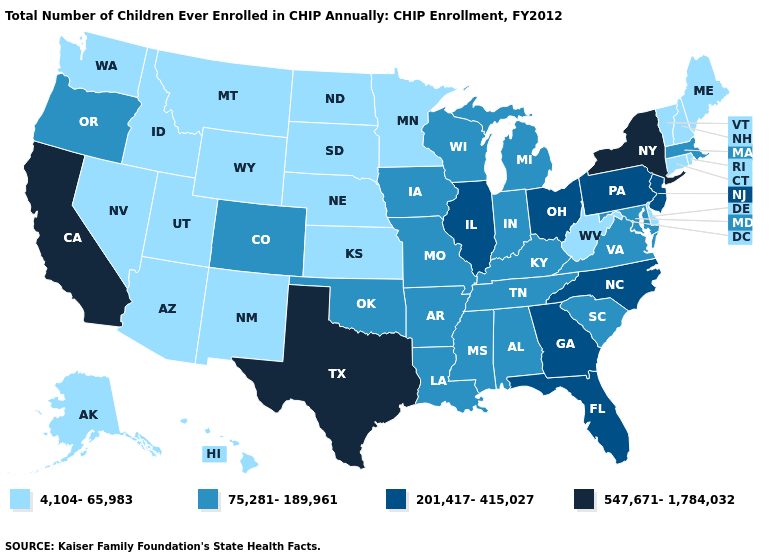Does Oregon have a higher value than Minnesota?
Short answer required. Yes. Does the first symbol in the legend represent the smallest category?
Concise answer only. Yes. What is the value of Louisiana?
Give a very brief answer. 75,281-189,961. Name the states that have a value in the range 201,417-415,027?
Concise answer only. Florida, Georgia, Illinois, New Jersey, North Carolina, Ohio, Pennsylvania. Does Oklahoma have a higher value than Alabama?
Be succinct. No. Does Louisiana have a lower value than California?
Keep it brief. Yes. Among the states that border Massachusetts , does New York have the highest value?
Short answer required. Yes. Among the states that border Connecticut , which have the lowest value?
Be succinct. Rhode Island. Does California have a higher value than New York?
Keep it brief. No. Name the states that have a value in the range 4,104-65,983?
Write a very short answer. Alaska, Arizona, Connecticut, Delaware, Hawaii, Idaho, Kansas, Maine, Minnesota, Montana, Nebraska, Nevada, New Hampshire, New Mexico, North Dakota, Rhode Island, South Dakota, Utah, Vermont, Washington, West Virginia, Wyoming. Name the states that have a value in the range 4,104-65,983?
Short answer required. Alaska, Arizona, Connecticut, Delaware, Hawaii, Idaho, Kansas, Maine, Minnesota, Montana, Nebraska, Nevada, New Hampshire, New Mexico, North Dakota, Rhode Island, South Dakota, Utah, Vermont, Washington, West Virginia, Wyoming. Among the states that border Pennsylvania , does Ohio have the highest value?
Write a very short answer. No. Name the states that have a value in the range 201,417-415,027?
Quick response, please. Florida, Georgia, Illinois, New Jersey, North Carolina, Ohio, Pennsylvania. What is the lowest value in states that border North Dakota?
Answer briefly. 4,104-65,983. Which states hav the highest value in the MidWest?
Give a very brief answer. Illinois, Ohio. 